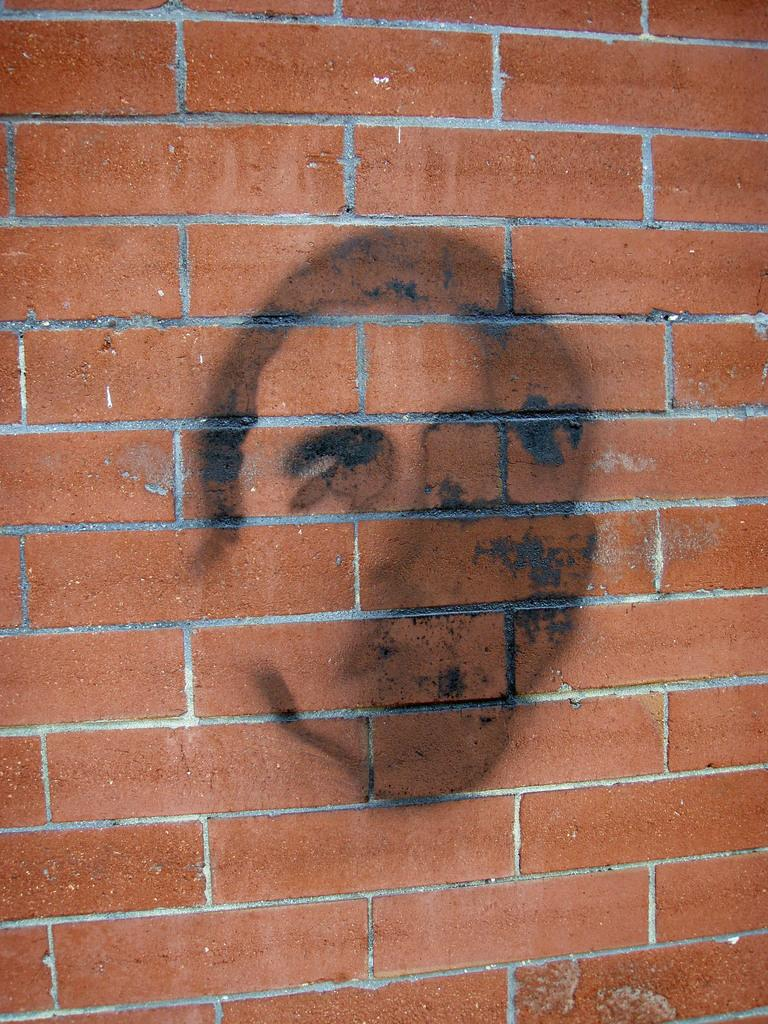What can be seen in the image? There is a wall in the image. What is on the wall? There is a drawing on the wall. What type of appliance is being used by the maid in the image? There is no appliance or maid present in the image; it only features a wall with a drawing on it. 